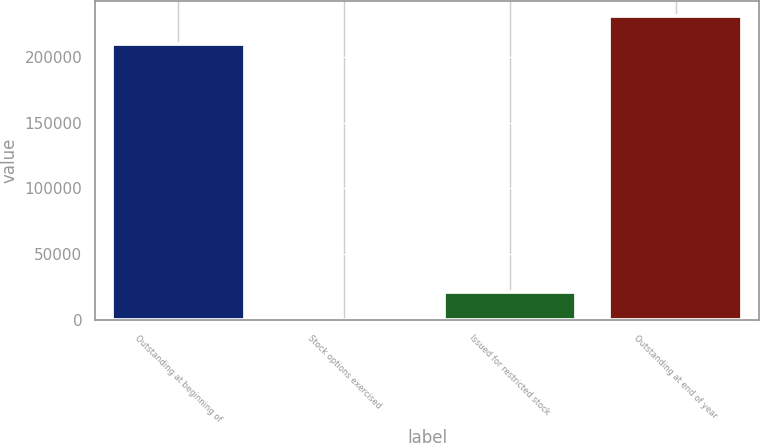Convert chart to OTSL. <chart><loc_0><loc_0><loc_500><loc_500><bar_chart><fcel>Outstanding at beginning of<fcel>Stock options exercised<fcel>Issued for restricted stock<fcel>Outstanding at end of year<nl><fcel>209546<fcel>68<fcel>21190.1<fcel>230668<nl></chart> 